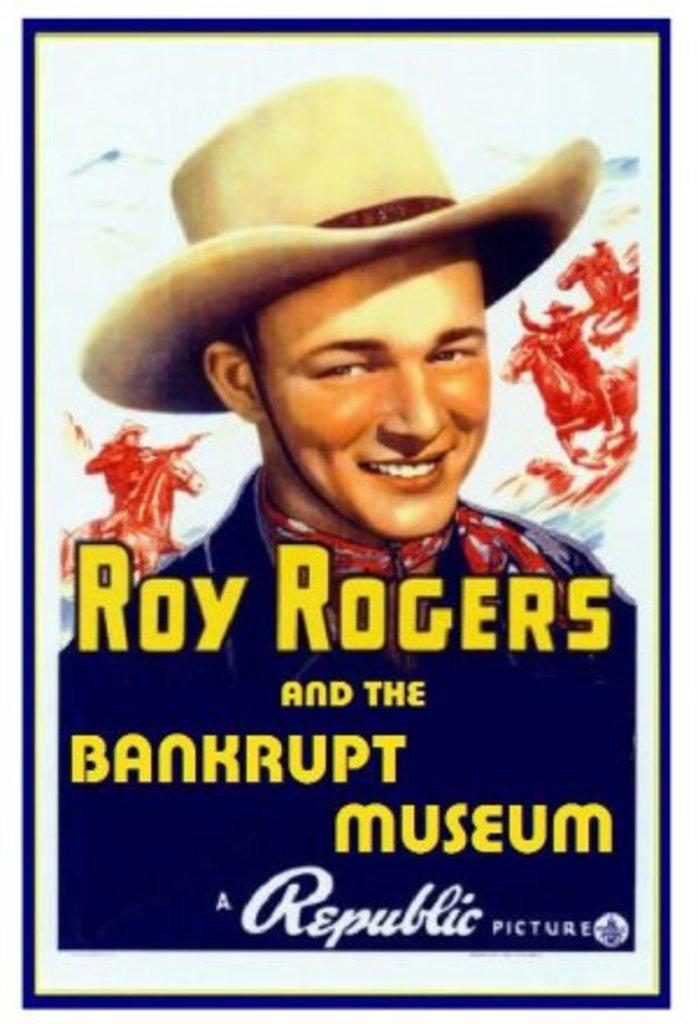Provide a one-sentence caption for the provided image. A poster for Roy Rogers and the Bankrupt Museum. 